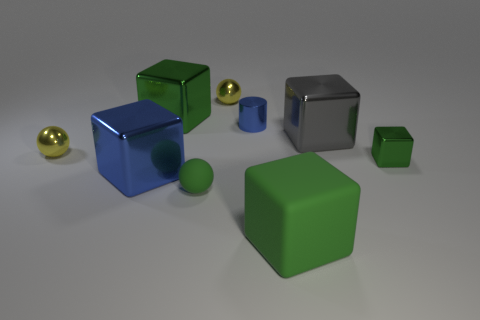How many objects are things that are to the left of the big green rubber thing or big metallic objects to the right of the small green sphere?
Your response must be concise. 7. There is a green thing that is the same size as the green rubber ball; what shape is it?
Offer a terse response. Cube. What is the size of the blue cylinder that is made of the same material as the gray thing?
Ensure brevity in your answer.  Small. Is the shape of the large gray metallic thing the same as the large blue thing?
Provide a succinct answer. Yes. What color is the metal cylinder that is the same size as the rubber sphere?
Offer a terse response. Blue. What size is the other matte thing that is the same shape as the gray thing?
Make the answer very short. Large. There is a tiny metallic object behind the small blue cylinder; what shape is it?
Your response must be concise. Sphere. Do the tiny rubber thing and the small yellow object that is behind the tiny blue cylinder have the same shape?
Your response must be concise. Yes. Are there an equal number of large green matte cubes left of the blue cube and tiny metal blocks that are behind the tiny blue cylinder?
Your answer should be very brief. Yes. There is a small metal object that is the same color as the small rubber sphere; what shape is it?
Make the answer very short. Cube. 